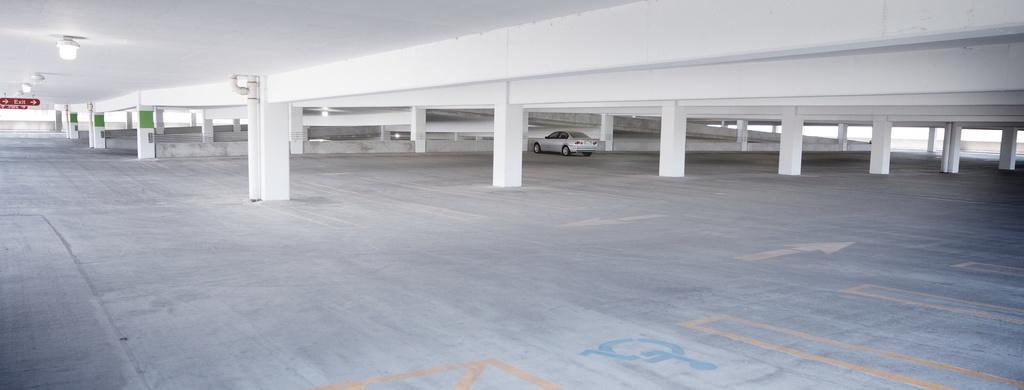How would you summarize this image in a sentence or two? In this image we can see a car parked on the floor, there are few pillars, lights and sign boards attached to the ceiling. 